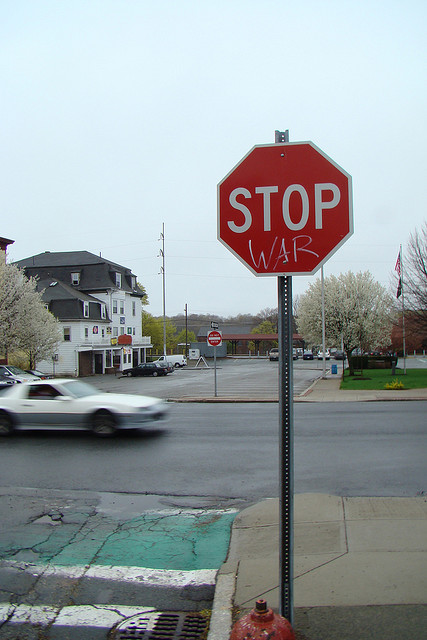What does the altered stop sign suggest about the community's stance on certain issues? The altered stop sign with the message 'STOP WAR' suggests that members of this community feel strongly about advocating for peace and are against war. It's a unique and public display of political activism, indicating that the community is engaged and perhaps encouraging passersby to consider the ramifications of conflict. 